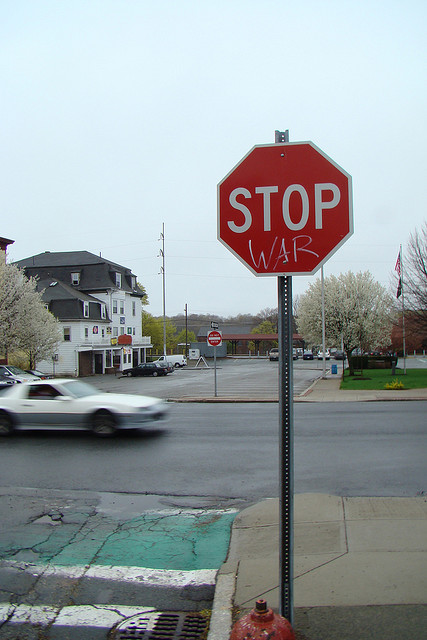What does the altered stop sign suggest about the community's stance on certain issues? The altered stop sign with the message 'STOP WAR' suggests that members of this community feel strongly about advocating for peace and are against war. It's a unique and public display of political activism, indicating that the community is engaged and perhaps encouraging passersby to consider the ramifications of conflict. 